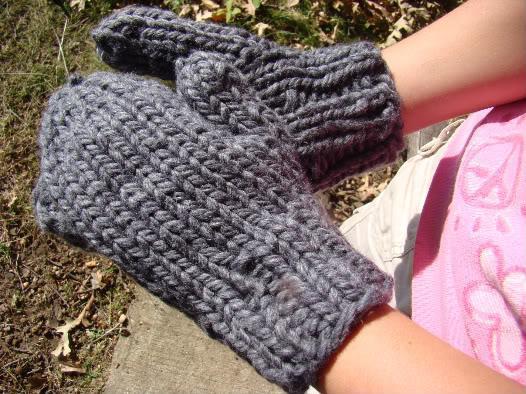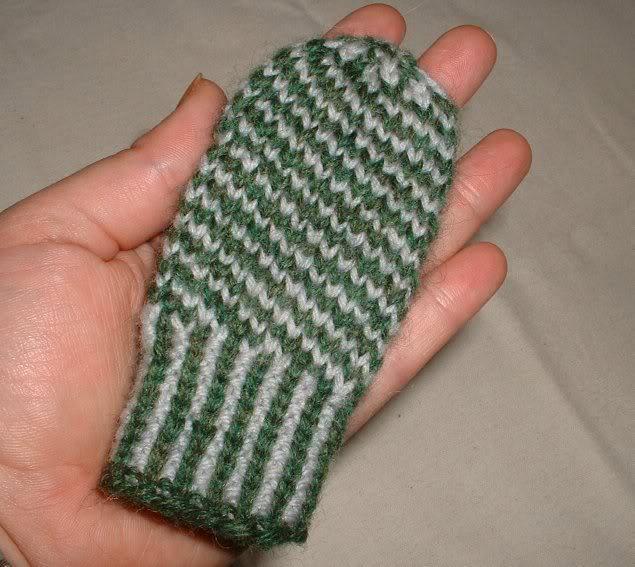The first image is the image on the left, the second image is the image on the right. Examine the images to the left and right. Is the description "One image shows at least one knitted mitten modelled on a human hand." accurate? Answer yes or no. Yes. The first image is the image on the left, the second image is the image on the right. Assess this claim about the two images: "The right image contains at least two mittens.". Correct or not? Answer yes or no. No. 